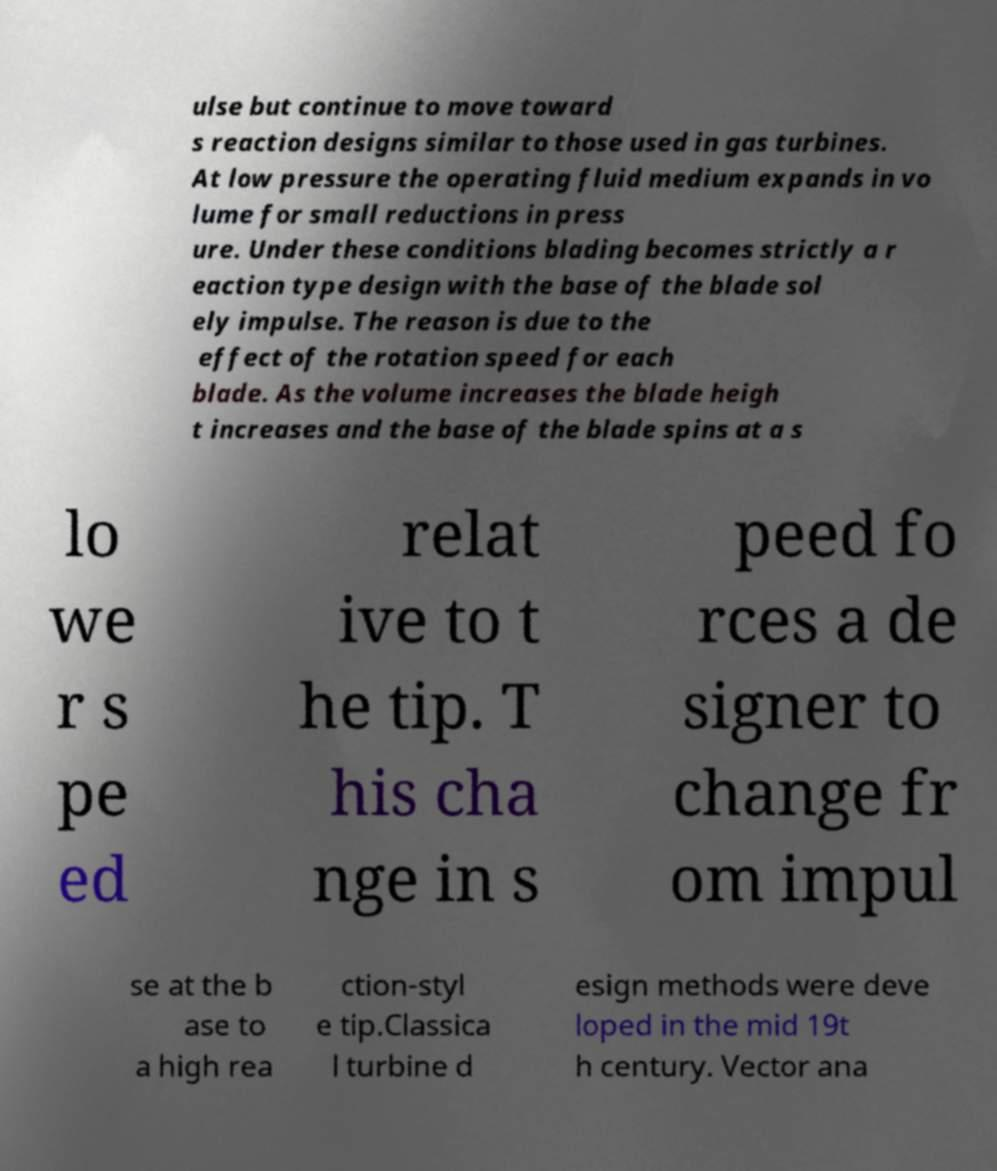For documentation purposes, I need the text within this image transcribed. Could you provide that? ulse but continue to move toward s reaction designs similar to those used in gas turbines. At low pressure the operating fluid medium expands in vo lume for small reductions in press ure. Under these conditions blading becomes strictly a r eaction type design with the base of the blade sol ely impulse. The reason is due to the effect of the rotation speed for each blade. As the volume increases the blade heigh t increases and the base of the blade spins at a s lo we r s pe ed relat ive to t he tip. T his cha nge in s peed fo rces a de signer to change fr om impul se at the b ase to a high rea ction-styl e tip.Classica l turbine d esign methods were deve loped in the mid 19t h century. Vector ana 